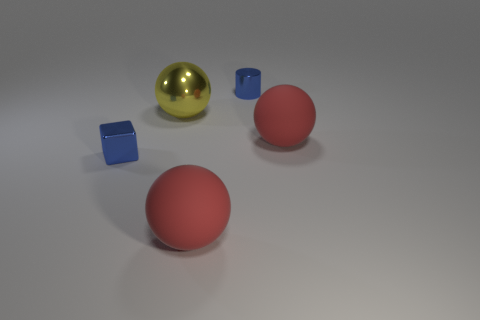Add 2 small blue shiny spheres. How many objects exist? 7 Subtract all cubes. How many objects are left? 4 Subtract all blue metal things. Subtract all big metallic spheres. How many objects are left? 2 Add 2 tiny blue things. How many tiny blue things are left? 4 Add 1 tiny blue metal cylinders. How many tiny blue metal cylinders exist? 2 Subtract 1 yellow balls. How many objects are left? 4 